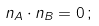Convert formula to latex. <formula><loc_0><loc_0><loc_500><loc_500>n _ { A } \cdot n _ { B } = 0 \, ;</formula> 